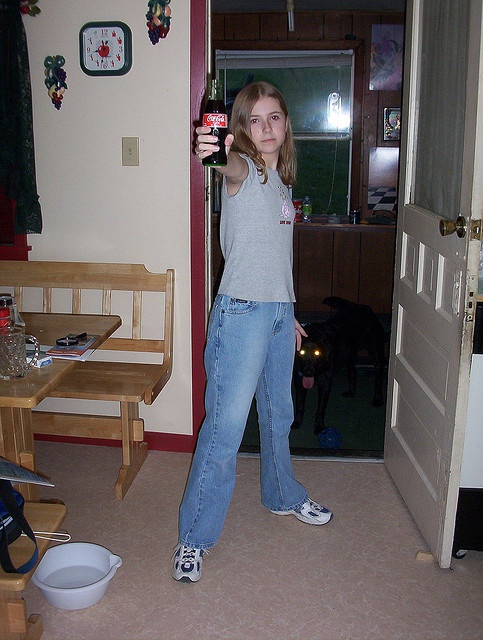Describe the objects in this image and their specific colors. I can see people in black, gray, and darkgray tones, bench in black, maroon, darkgray, and gray tones, dining table in black, maroon, and gray tones, dog in black, maroon, gray, and purple tones, and bowl in black, darkgray, and gray tones in this image. 